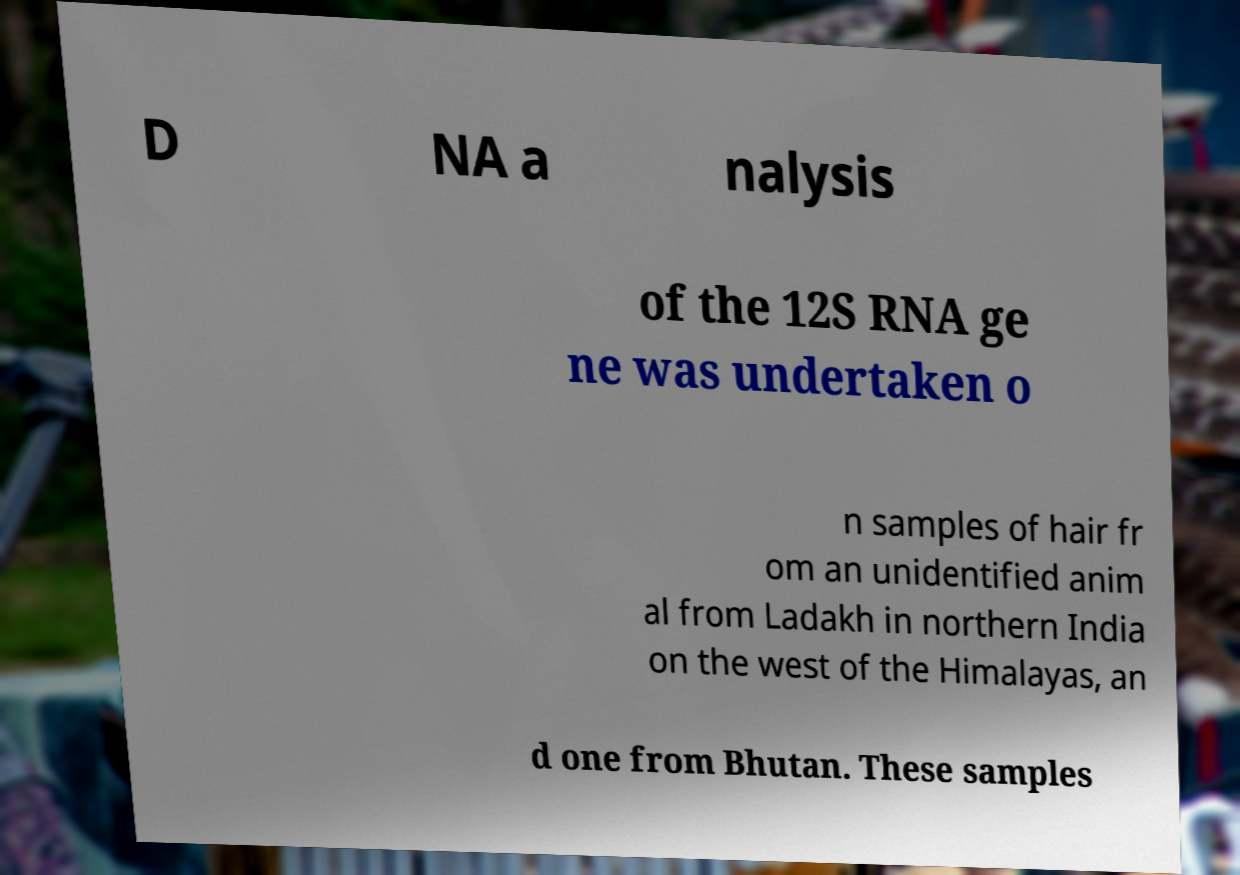I need the written content from this picture converted into text. Can you do that? D NA a nalysis of the 12S RNA ge ne was undertaken o n samples of hair fr om an unidentified anim al from Ladakh in northern India on the west of the Himalayas, an d one from Bhutan. These samples 